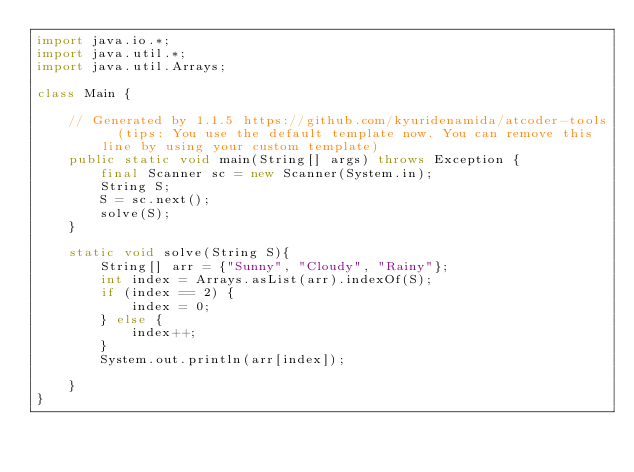Convert code to text. <code><loc_0><loc_0><loc_500><loc_500><_Java_>import java.io.*;
import java.util.*;
import java.util.Arrays;

class Main {

    // Generated by 1.1.5 https://github.com/kyuridenamida/atcoder-tools  (tips: You use the default template now. You can remove this line by using your custom template)
    public static void main(String[] args) throws Exception {
        final Scanner sc = new Scanner(System.in);
        String S;
        S = sc.next();
        solve(S);
    }

    static void solve(String S){
        String[] arr = {"Sunny", "Cloudy", "Rainy"};
        int index = Arrays.asList(arr).indexOf(S);
        if (index == 2) {
            index = 0;
        } else {
            index++;
        }
        System.out.println(arr[index]);

    }
}</code> 